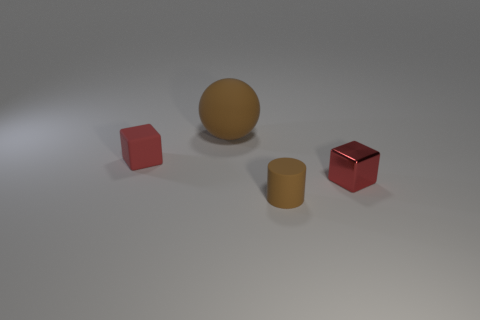Are there any large rubber objects that have the same shape as the small red metallic object? In the image, there is a large, rubber object that resembles the small red metallic object in shape. Both appear to be cubes, with the rubber one being larger in size and yellow in color. 